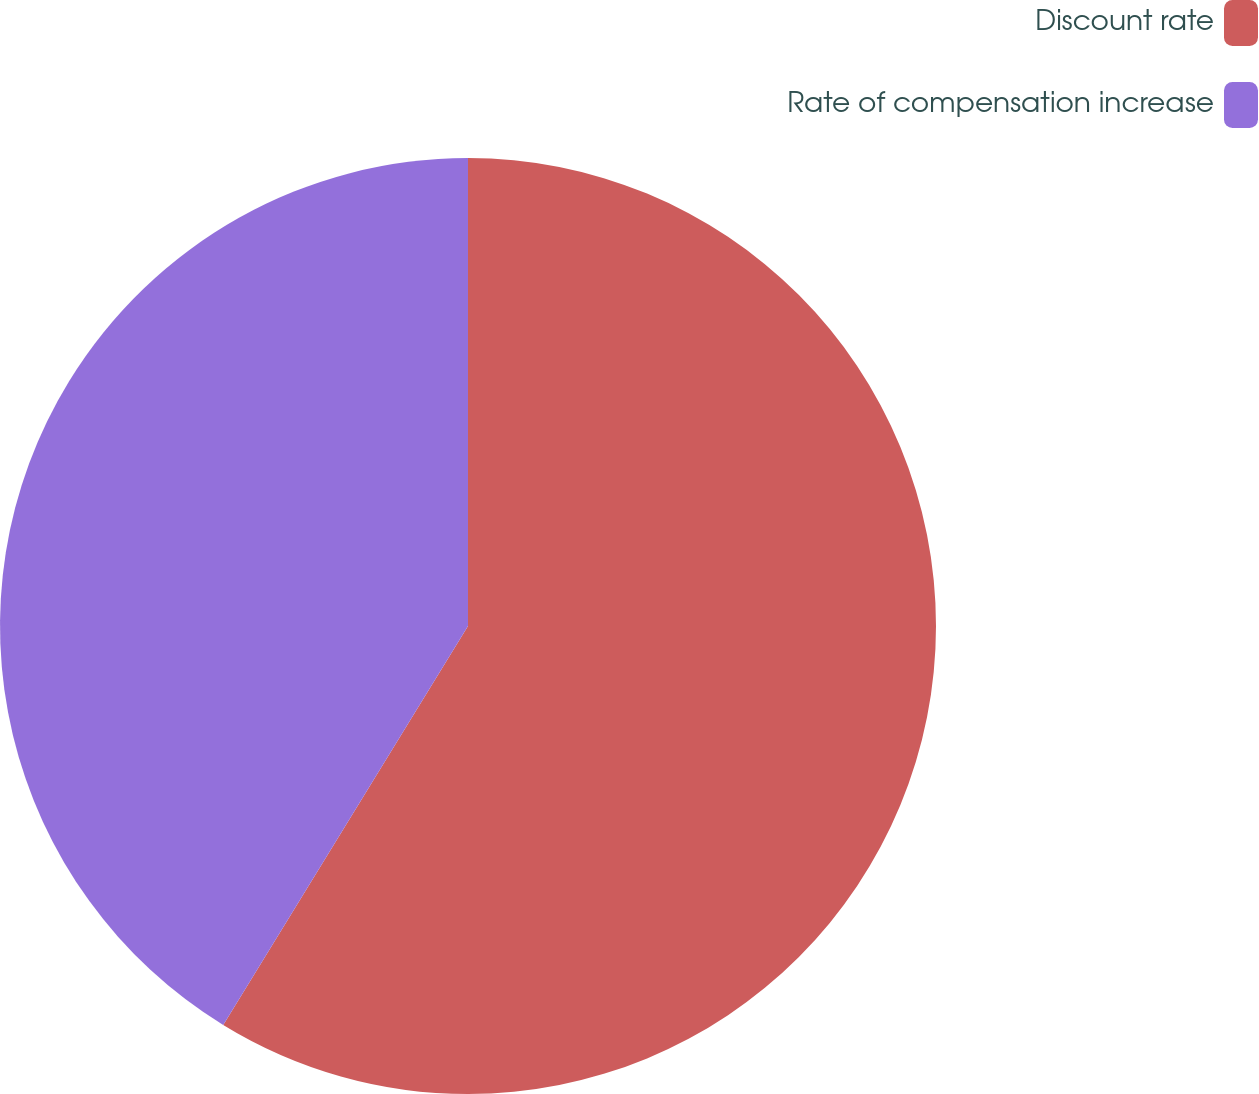Convert chart to OTSL. <chart><loc_0><loc_0><loc_500><loc_500><pie_chart><fcel>Discount rate<fcel>Rate of compensation increase<nl><fcel>58.76%<fcel>41.24%<nl></chart> 